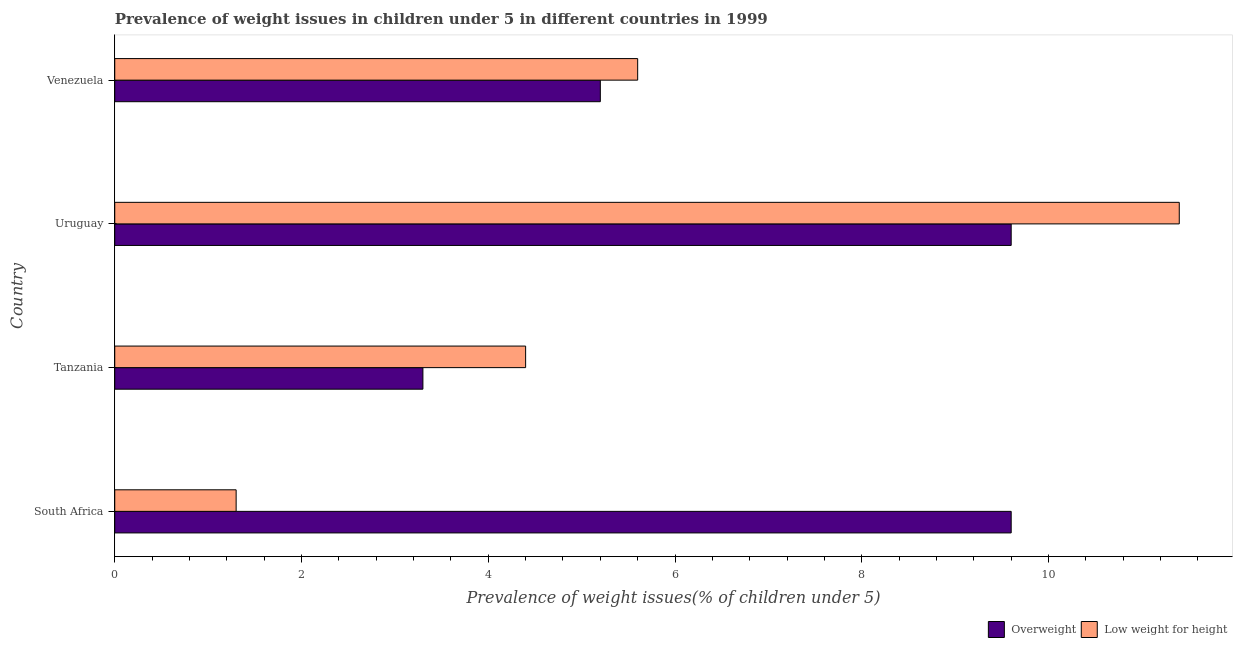Are the number of bars per tick equal to the number of legend labels?
Your response must be concise. Yes. How many bars are there on the 1st tick from the top?
Keep it short and to the point. 2. How many bars are there on the 1st tick from the bottom?
Provide a succinct answer. 2. What is the label of the 1st group of bars from the top?
Your answer should be very brief. Venezuela. What is the percentage of underweight children in Venezuela?
Your answer should be very brief. 5.6. Across all countries, what is the maximum percentage of underweight children?
Ensure brevity in your answer.  11.4. Across all countries, what is the minimum percentage of overweight children?
Provide a succinct answer. 3.3. In which country was the percentage of underweight children maximum?
Your answer should be very brief. Uruguay. In which country was the percentage of underweight children minimum?
Your response must be concise. South Africa. What is the total percentage of underweight children in the graph?
Provide a short and direct response. 22.7. What is the difference between the percentage of overweight children in Uruguay and the percentage of underweight children in South Africa?
Keep it short and to the point. 8.3. What is the average percentage of underweight children per country?
Your answer should be compact. 5.67. What is the ratio of the percentage of underweight children in Tanzania to that in Uruguay?
Provide a succinct answer. 0.39. Is the difference between the percentage of underweight children in Tanzania and Uruguay greater than the difference between the percentage of overweight children in Tanzania and Uruguay?
Your response must be concise. No. What is the difference between the highest and the second highest percentage of overweight children?
Your answer should be very brief. 0. What does the 1st bar from the top in Venezuela represents?
Provide a short and direct response. Low weight for height. What does the 2nd bar from the bottom in Tanzania represents?
Your answer should be compact. Low weight for height. Are all the bars in the graph horizontal?
Ensure brevity in your answer.  Yes. Are the values on the major ticks of X-axis written in scientific E-notation?
Keep it short and to the point. No. Where does the legend appear in the graph?
Keep it short and to the point. Bottom right. How many legend labels are there?
Offer a very short reply. 2. How are the legend labels stacked?
Ensure brevity in your answer.  Horizontal. What is the title of the graph?
Your response must be concise. Prevalence of weight issues in children under 5 in different countries in 1999. Does "Female labourers" appear as one of the legend labels in the graph?
Offer a very short reply. No. What is the label or title of the X-axis?
Your answer should be very brief. Prevalence of weight issues(% of children under 5). What is the Prevalence of weight issues(% of children under 5) of Overweight in South Africa?
Ensure brevity in your answer.  9.6. What is the Prevalence of weight issues(% of children under 5) in Low weight for height in South Africa?
Your response must be concise. 1.3. What is the Prevalence of weight issues(% of children under 5) of Overweight in Tanzania?
Offer a very short reply. 3.3. What is the Prevalence of weight issues(% of children under 5) of Low weight for height in Tanzania?
Provide a short and direct response. 4.4. What is the Prevalence of weight issues(% of children under 5) of Overweight in Uruguay?
Offer a terse response. 9.6. What is the Prevalence of weight issues(% of children under 5) of Low weight for height in Uruguay?
Provide a short and direct response. 11.4. What is the Prevalence of weight issues(% of children under 5) in Overweight in Venezuela?
Make the answer very short. 5.2. What is the Prevalence of weight issues(% of children under 5) of Low weight for height in Venezuela?
Offer a terse response. 5.6. Across all countries, what is the maximum Prevalence of weight issues(% of children under 5) of Overweight?
Your answer should be compact. 9.6. Across all countries, what is the maximum Prevalence of weight issues(% of children under 5) of Low weight for height?
Provide a short and direct response. 11.4. Across all countries, what is the minimum Prevalence of weight issues(% of children under 5) in Overweight?
Keep it short and to the point. 3.3. Across all countries, what is the minimum Prevalence of weight issues(% of children under 5) in Low weight for height?
Provide a succinct answer. 1.3. What is the total Prevalence of weight issues(% of children under 5) of Overweight in the graph?
Your answer should be compact. 27.7. What is the total Prevalence of weight issues(% of children under 5) in Low weight for height in the graph?
Your response must be concise. 22.7. What is the difference between the Prevalence of weight issues(% of children under 5) of Overweight in South Africa and that in Tanzania?
Your response must be concise. 6.3. What is the difference between the Prevalence of weight issues(% of children under 5) in Low weight for height in South Africa and that in Venezuela?
Your answer should be very brief. -4.3. What is the difference between the Prevalence of weight issues(% of children under 5) in Overweight in Tanzania and that in Uruguay?
Provide a succinct answer. -6.3. What is the difference between the Prevalence of weight issues(% of children under 5) in Overweight in Tanzania and that in Venezuela?
Keep it short and to the point. -1.9. What is the difference between the Prevalence of weight issues(% of children under 5) of Low weight for height in Tanzania and that in Venezuela?
Your answer should be compact. -1.2. What is the difference between the Prevalence of weight issues(% of children under 5) of Overweight in South Africa and the Prevalence of weight issues(% of children under 5) of Low weight for height in Tanzania?
Make the answer very short. 5.2. What is the difference between the Prevalence of weight issues(% of children under 5) in Overweight in South Africa and the Prevalence of weight issues(% of children under 5) in Low weight for height in Uruguay?
Keep it short and to the point. -1.8. What is the difference between the Prevalence of weight issues(% of children under 5) in Overweight in South Africa and the Prevalence of weight issues(% of children under 5) in Low weight for height in Venezuela?
Keep it short and to the point. 4. What is the difference between the Prevalence of weight issues(% of children under 5) of Overweight in Tanzania and the Prevalence of weight issues(% of children under 5) of Low weight for height in Venezuela?
Your answer should be very brief. -2.3. What is the average Prevalence of weight issues(% of children under 5) of Overweight per country?
Offer a very short reply. 6.92. What is the average Prevalence of weight issues(% of children under 5) of Low weight for height per country?
Keep it short and to the point. 5.67. What is the difference between the Prevalence of weight issues(% of children under 5) of Overweight and Prevalence of weight issues(% of children under 5) of Low weight for height in Tanzania?
Offer a terse response. -1.1. What is the difference between the Prevalence of weight issues(% of children under 5) in Overweight and Prevalence of weight issues(% of children under 5) in Low weight for height in Venezuela?
Offer a very short reply. -0.4. What is the ratio of the Prevalence of weight issues(% of children under 5) of Overweight in South Africa to that in Tanzania?
Provide a succinct answer. 2.91. What is the ratio of the Prevalence of weight issues(% of children under 5) of Low weight for height in South Africa to that in Tanzania?
Your answer should be very brief. 0.3. What is the ratio of the Prevalence of weight issues(% of children under 5) of Overweight in South Africa to that in Uruguay?
Ensure brevity in your answer.  1. What is the ratio of the Prevalence of weight issues(% of children under 5) in Low weight for height in South Africa to that in Uruguay?
Your answer should be compact. 0.11. What is the ratio of the Prevalence of weight issues(% of children under 5) in Overweight in South Africa to that in Venezuela?
Your response must be concise. 1.85. What is the ratio of the Prevalence of weight issues(% of children under 5) in Low weight for height in South Africa to that in Venezuela?
Provide a short and direct response. 0.23. What is the ratio of the Prevalence of weight issues(% of children under 5) of Overweight in Tanzania to that in Uruguay?
Offer a very short reply. 0.34. What is the ratio of the Prevalence of weight issues(% of children under 5) in Low weight for height in Tanzania to that in Uruguay?
Your response must be concise. 0.39. What is the ratio of the Prevalence of weight issues(% of children under 5) in Overweight in Tanzania to that in Venezuela?
Your response must be concise. 0.63. What is the ratio of the Prevalence of weight issues(% of children under 5) of Low weight for height in Tanzania to that in Venezuela?
Your answer should be very brief. 0.79. What is the ratio of the Prevalence of weight issues(% of children under 5) of Overweight in Uruguay to that in Venezuela?
Ensure brevity in your answer.  1.85. What is the ratio of the Prevalence of weight issues(% of children under 5) in Low weight for height in Uruguay to that in Venezuela?
Provide a succinct answer. 2.04. What is the difference between the highest and the second highest Prevalence of weight issues(% of children under 5) in Overweight?
Ensure brevity in your answer.  0. What is the difference between the highest and the second highest Prevalence of weight issues(% of children under 5) in Low weight for height?
Provide a succinct answer. 5.8. What is the difference between the highest and the lowest Prevalence of weight issues(% of children under 5) in Low weight for height?
Provide a succinct answer. 10.1. 